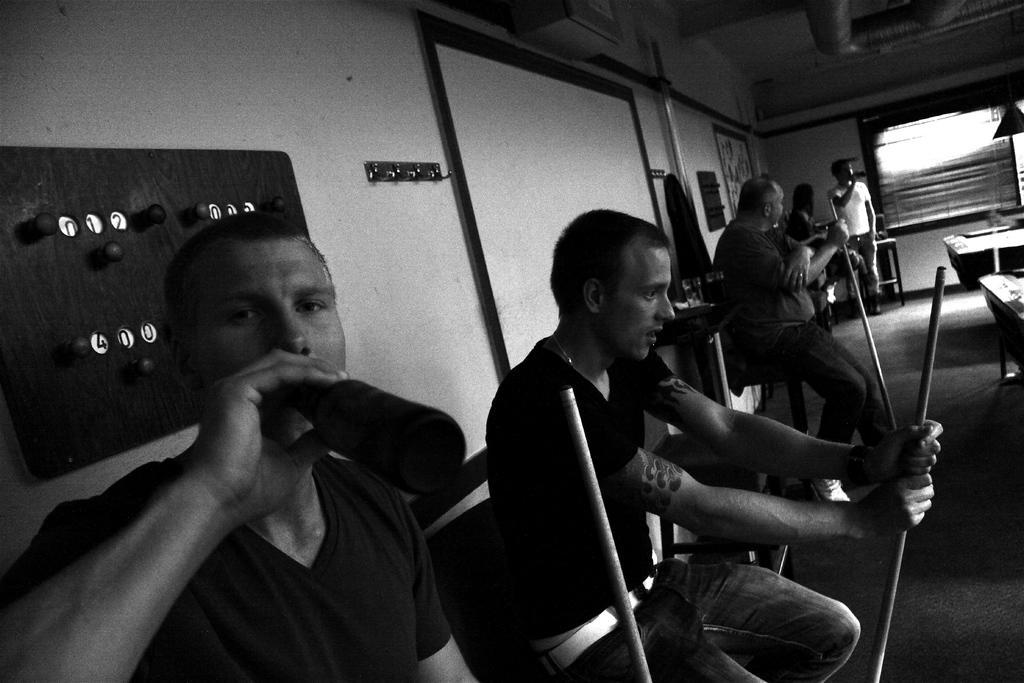In one or two sentences, can you explain what this image depicts? To the bottom left of the image there is a man holding the bottle in his hand and drinking. Beside him there is a man with black t-shirt is sitting and holding the stick in his hand. Behind them there is a wall with board and hanger. Also there are screen, frame and some other items on it. In the background there are few people. To the right corner of the image there is a window and to the top of the image to the right side there are tubes. 